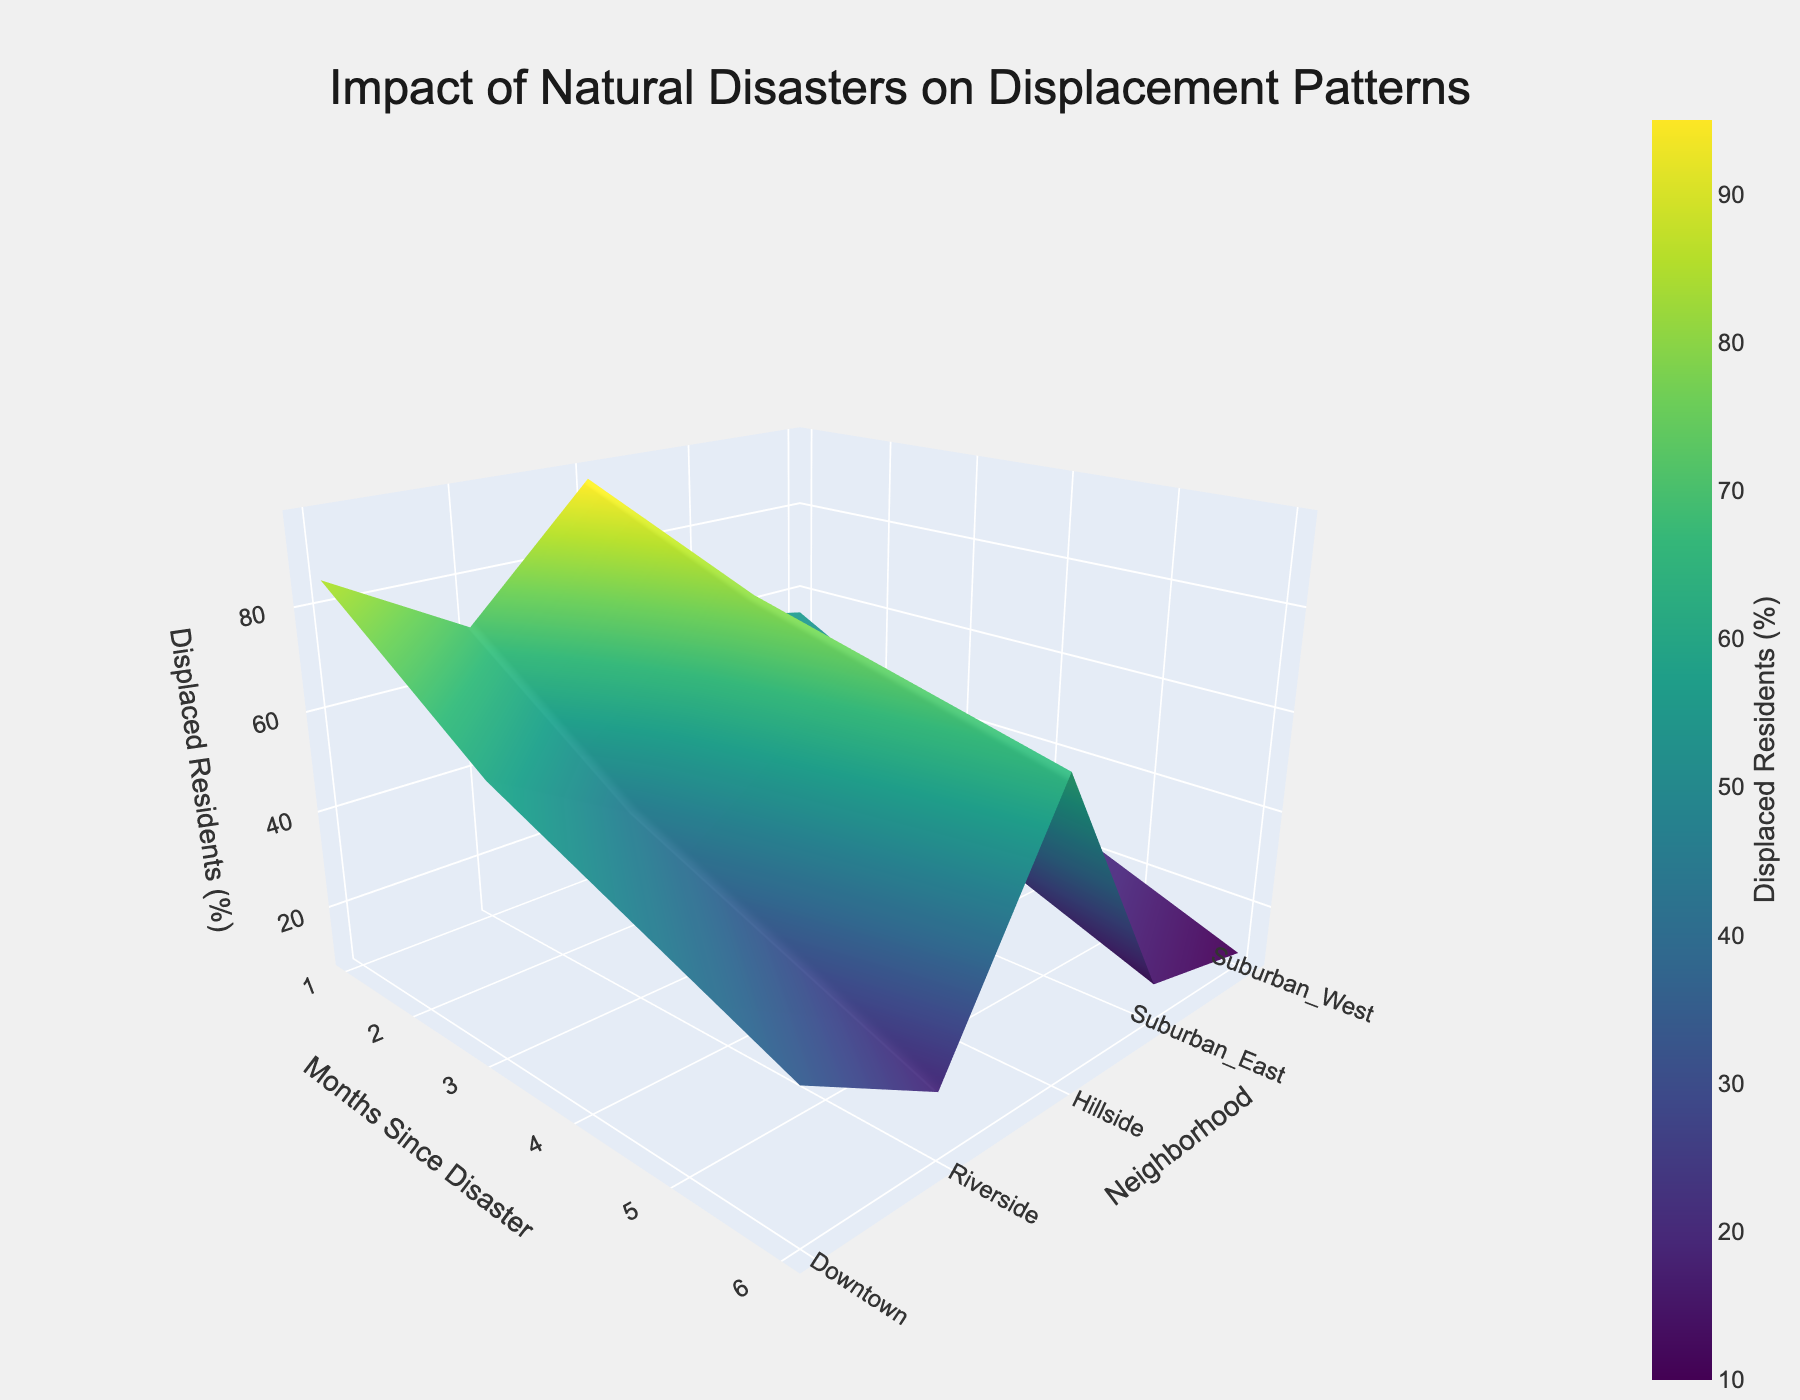What is the title of the plot? The title of the plot is typically displayed prominently at the top of the figure. In this case, it reads "Impact of Natural Disasters on Displacement Patterns".
Answer: Impact of Natural Disasters on Displacement Patterns What does the color bar represent? The color bar on the right side of the plot represents the percentage of displaced residents. The varying colors help to indicate different displacement percentages.
Answer: Displaced Residents (%) Which neighborhood had the highest initial displacement percentage one month after the disaster? Looking at the first month (x-axis), the tallest peaks represent the highest displacement percentages. The neighborhood with the highest peak in this view is Riverside.
Answer: Riverside How does the displacement percentage change for Downtown over time? Observing the surface plot from Downtown's axis, we see that the height (displacement percentage) decreases as we move along the months (x-axis). It starts high at Month 1 and gradually decreases by Month 6.
Answer: Decreases over time Which neighborhood shows the least displacement percentage after six months? To find this, locate the 6-month mark (x-axis) and look for the lowest peak along the y-axis (neighborhoods). The smallest peak is in the Suburban West neighborhood.
Answer: Suburban West Compare the displacement percentage of Riverside at Month 3 with Downtown at Month 6. Observing Riverside at Month 3 (middle of the x-axis) and Downtown at Month 6 (end of the x-axis), Riverside is higher on the z-axis (displacement percentage) compared to Downtown at Month 6.
Answer: Riverside is higher Which neighborhood shows the greatest improvement in displacement percentage from Month 1 to Month 6? Improvement can be measured by the largest drop in peak height. Comparing all neighborhoods from Month 1 to Month 6, Suburban West shows the greatest improvement as it drops from 55% to 10%.
Answer: Suburban West What general trend is observable in displacement patterns over time across all neighborhoods? Observing the figure from months 1 to 6 for all neighborhoods, a general downward trend (decrease in surface height) is noticeable, indicating reduced displacement percentages over time.
Answer: Downward trend 